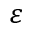Convert formula to latex. <formula><loc_0><loc_0><loc_500><loc_500>\varepsilon</formula> 